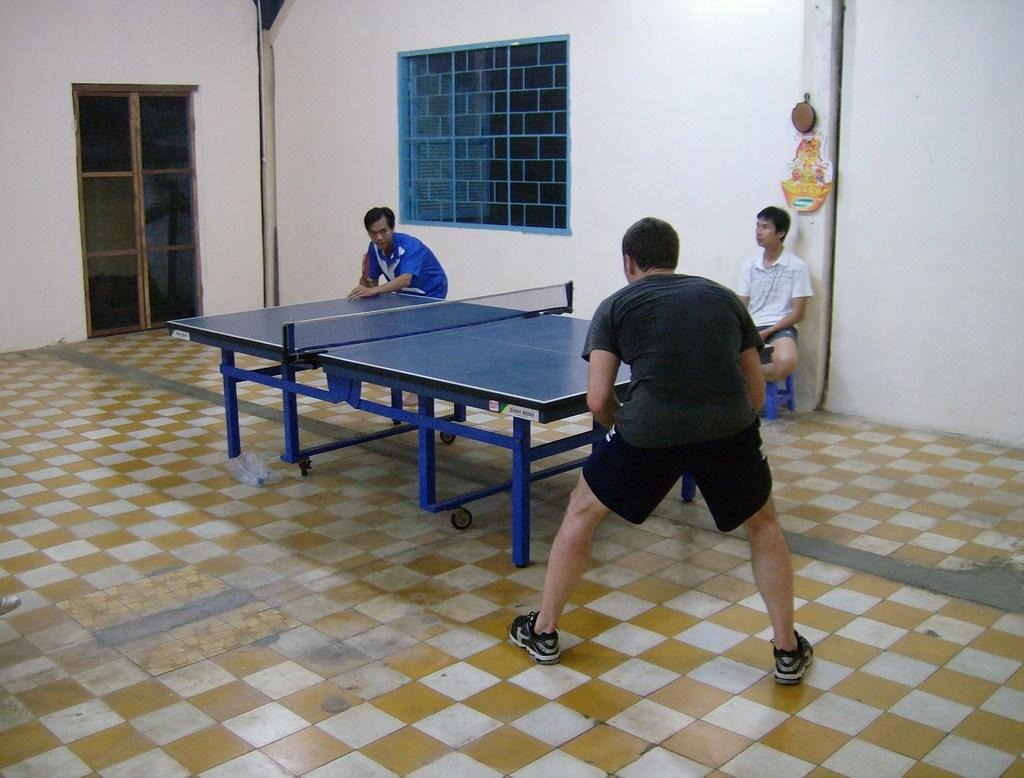How many people are present in the image? There are three people in the image: two standing around a table and one sitting on a stool. What are the people doing in the image? It is not clear what the people are doing, but they are gathered around a table. What can be seen in the background of the image? In the background, there is a window, a door, a wall, and a paper. Can you describe the setting of the image? The image appears to be set indoors, with a table, stool, and various background elements. What type of cars can be seen driving downtown in the image? There are no cars or downtown setting present in the image; it features three people and various background elements. 